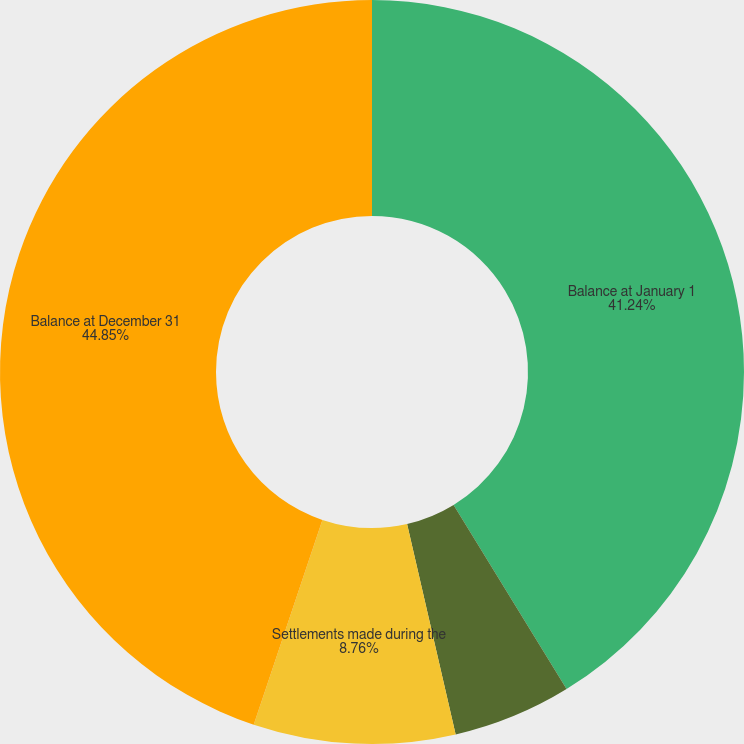<chart> <loc_0><loc_0><loc_500><loc_500><pie_chart><fcel>Balance at January 1<fcel>Adjustments for warranties<fcel>Settlements made during the<fcel>Balance at December 31<nl><fcel>41.24%<fcel>5.15%<fcel>8.76%<fcel>44.85%<nl></chart> 